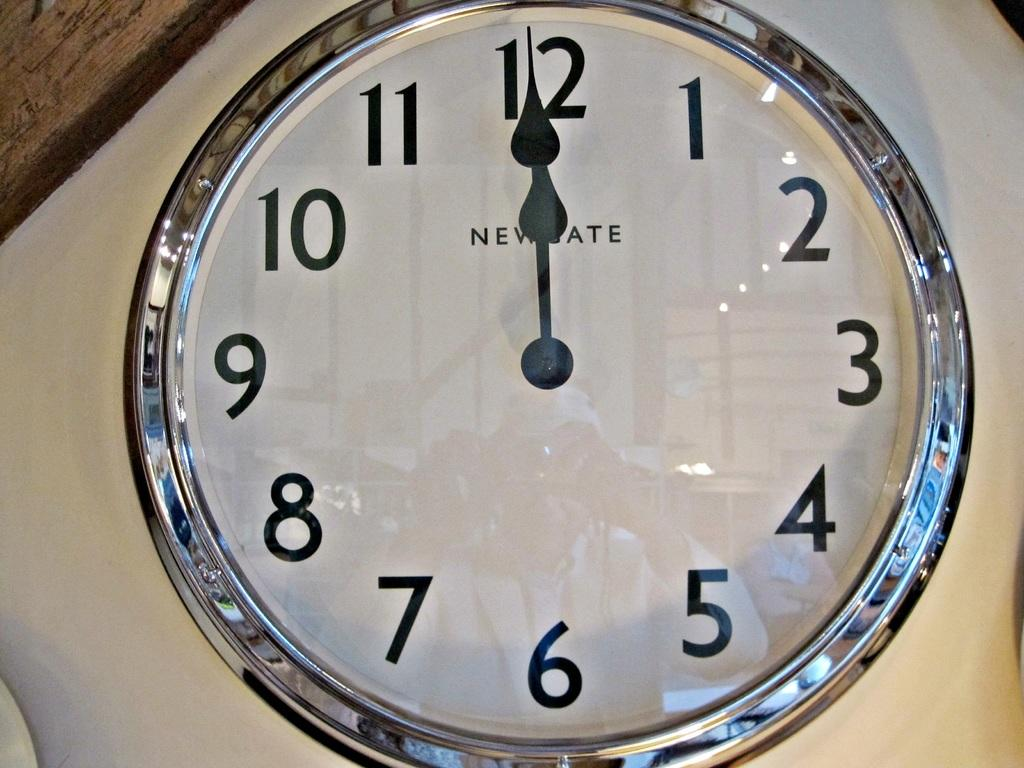Provide a one-sentence caption for the provided image. A glass analog wall clock with both hour and minute hands pointing at the 12. 